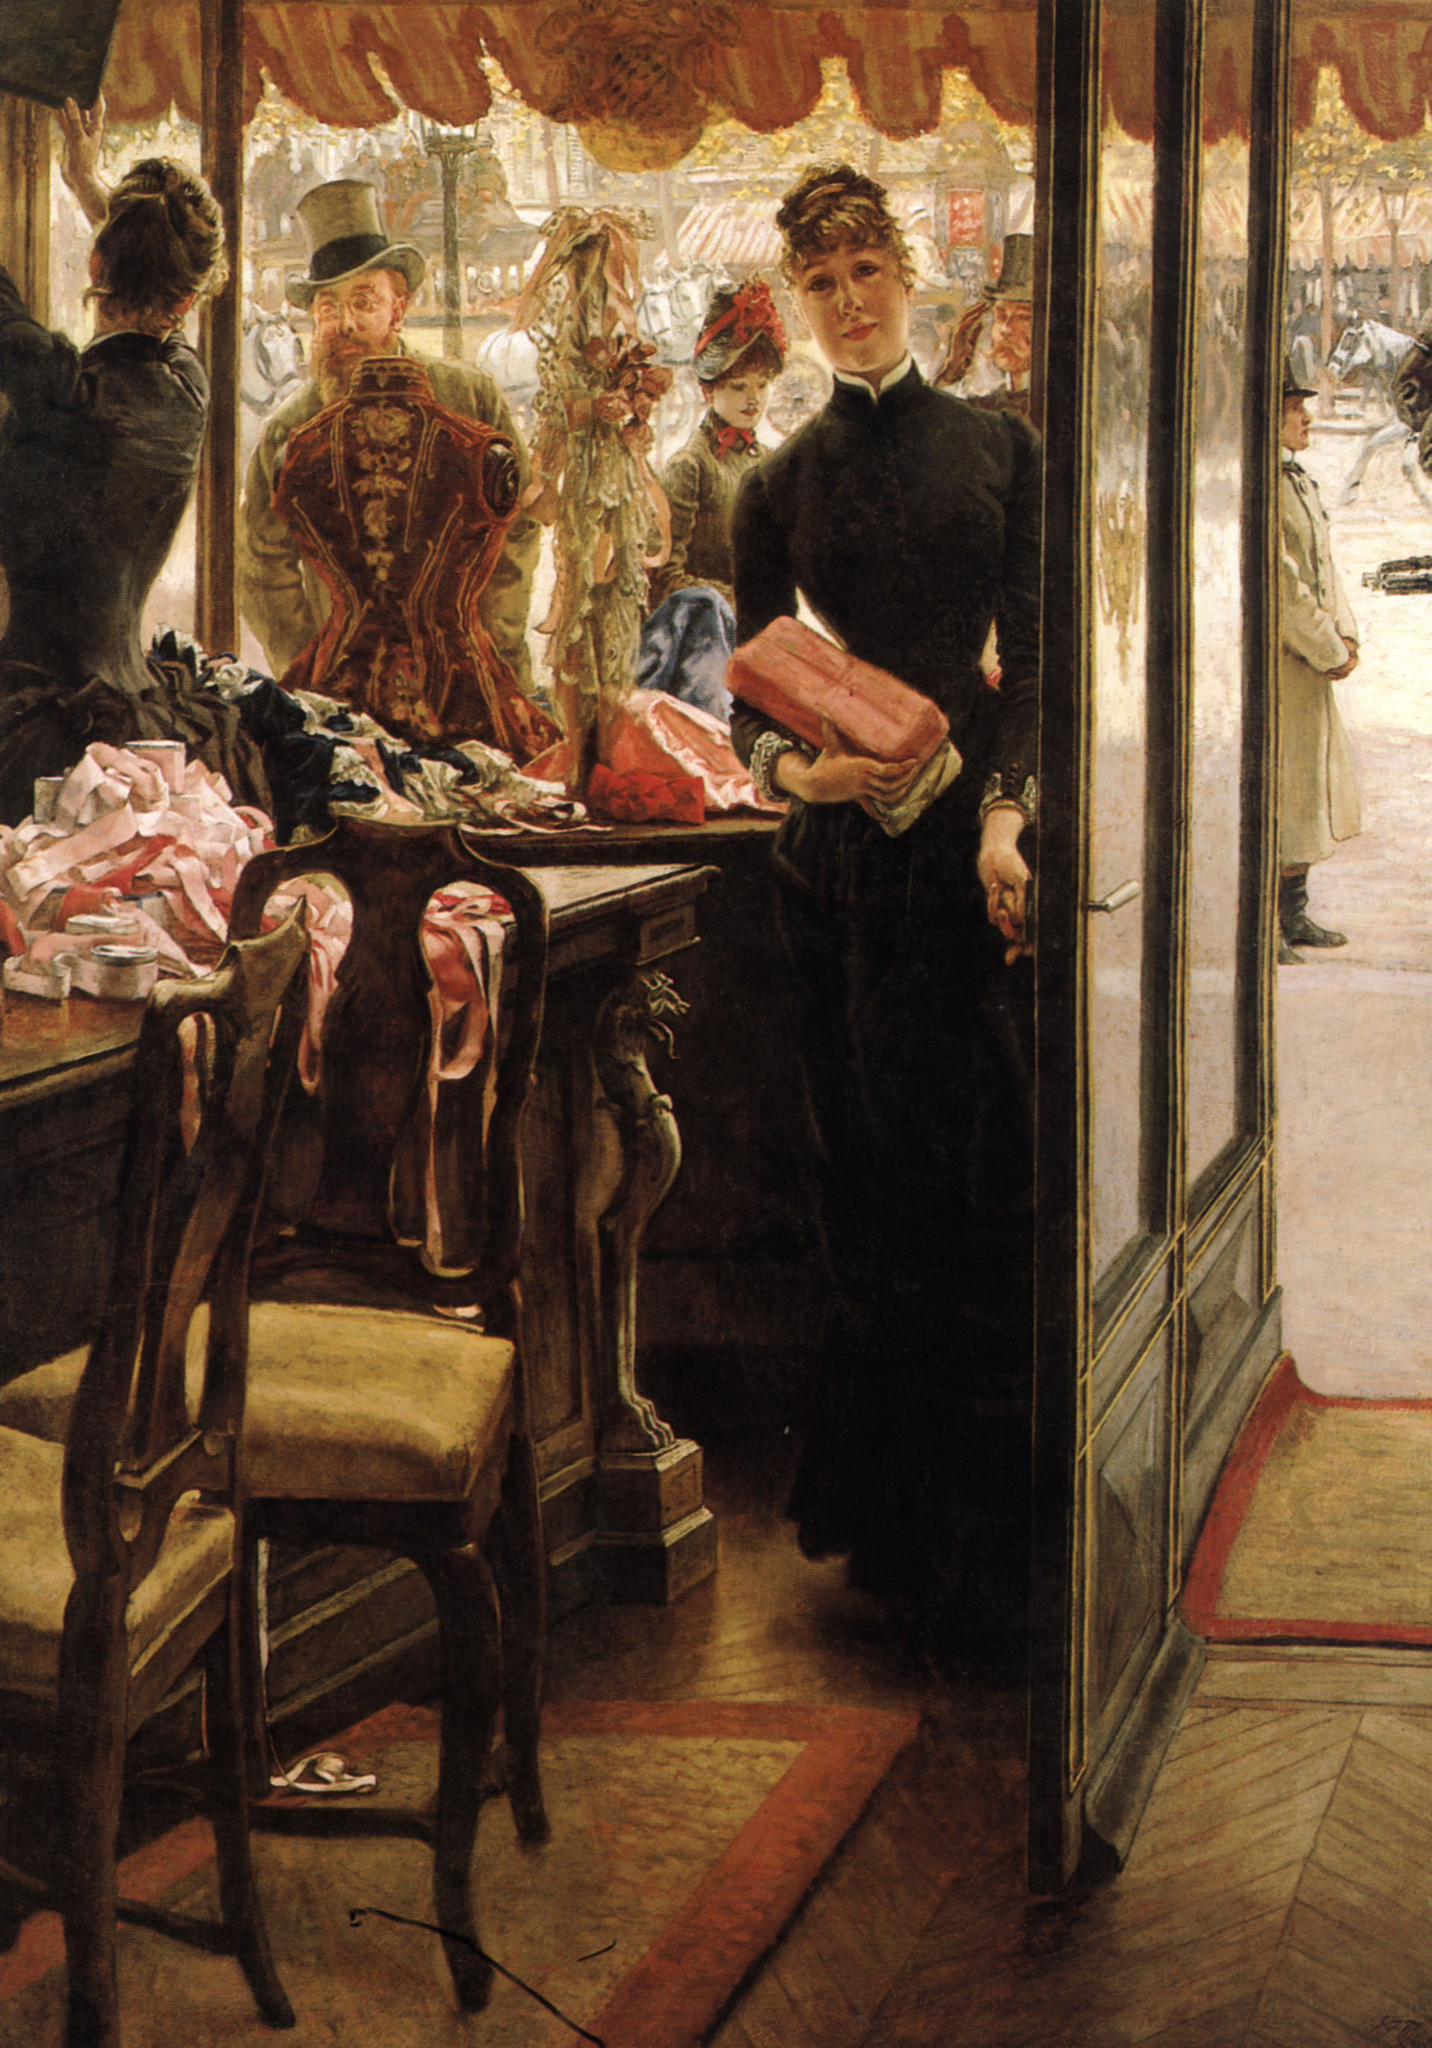If the shop girl had a secret, what do you think it might be? If the shop girl had a secret, it might be that she is not simply a shop assistant but the hidden heiress of the boutique’s wealthy owner. Perhaps, in disguise, she chose to work amongst the common people, seeking to understand their lives and struggles intimately. She might be secretly financing the education of her younger siblings, using her earnings to ensure their futures are brighter. Or, she could be part of a covert group that assists women in need, providing them with job opportunities at the boutique under various personas. Her secret life might be intertwined with acts of quiet rebellion against societal norms, intending to bring subtle but impactful changes to her world. 